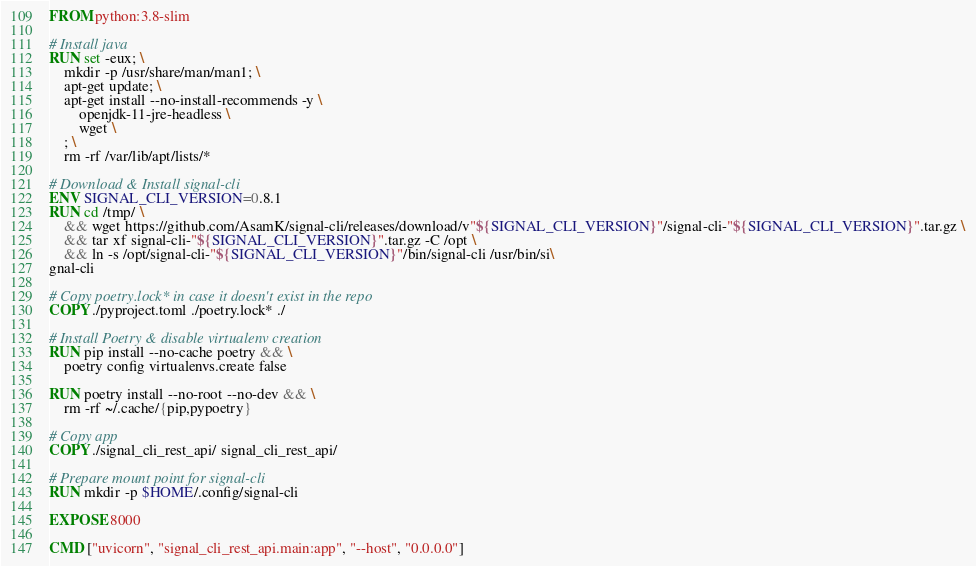Convert code to text. <code><loc_0><loc_0><loc_500><loc_500><_Dockerfile_>FROM python:3.8-slim

# Install java
RUN set -eux; \
    mkdir -p /usr/share/man/man1; \
    apt-get update; \
    apt-get install --no-install-recommends -y \
        openjdk-11-jre-headless \
        wget \
    ; \
    rm -rf /var/lib/apt/lists/*

# Download & Install signal-cli
ENV SIGNAL_CLI_VERSION=0.8.1
RUN cd /tmp/ \
    && wget https://github.com/AsamK/signal-cli/releases/download/v"${SIGNAL_CLI_VERSION}"/signal-cli-"${SIGNAL_CLI_VERSION}".tar.gz \
    && tar xf signal-cli-"${SIGNAL_CLI_VERSION}".tar.gz -C /opt \
    && ln -s /opt/signal-cli-"${SIGNAL_CLI_VERSION}"/bin/signal-cli /usr/bin/si\
gnal-cli

# Copy poetry.lock* in case it doesn't exist in the repo
COPY ./pyproject.toml ./poetry.lock* ./

# Install Poetry & disable virtualenv creation
RUN pip install --no-cache poetry && \
    poetry config virtualenvs.create false

RUN poetry install --no-root --no-dev && \
    rm -rf ~/.cache/{pip,pypoetry}

# Copy app
COPY ./signal_cli_rest_api/ signal_cli_rest_api/

# Prepare mount point for signal-cli 
RUN mkdir -p $HOME/.config/signal-cli

EXPOSE 8000

CMD ["uvicorn", "signal_cli_rest_api.main:app", "--host", "0.0.0.0"]</code> 